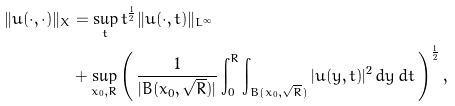Convert formula to latex. <formula><loc_0><loc_0><loc_500><loc_500>\| u ( \cdot , \cdot ) \| _ { X } & = \sup _ { t } t ^ { \frac { 1 } { 2 } } \| u ( \cdot , t ) \| _ { L ^ { \infty } } \\ & + \sup _ { x _ { 0 } , R } \left ( \, \frac { 1 } { | B ( x _ { 0 } , \sqrt { R } ) | } \int _ { 0 } ^ { R } \int _ { B ( x _ { 0 } , \sqrt { R } ) } | u ( y , t ) | ^ { 2 } \, d y \, d t \, \right ) ^ { \frac { 1 } { 2 } } ,</formula> 